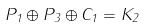Convert formula to latex. <formula><loc_0><loc_0><loc_500><loc_500>P _ { 1 } \oplus P _ { 3 } \oplus C _ { 1 } = K _ { 2 }</formula> 